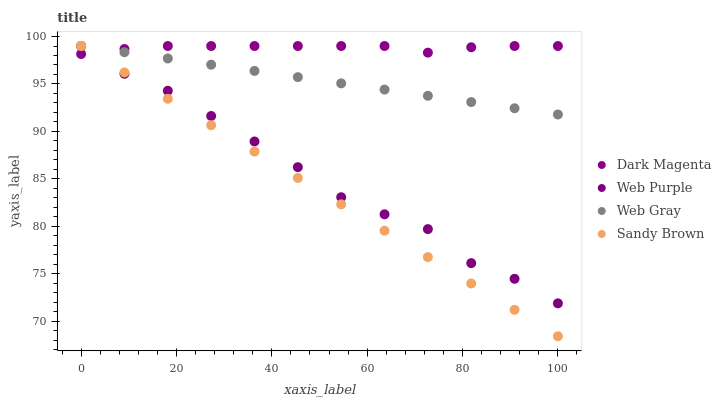Does Sandy Brown have the minimum area under the curve?
Answer yes or no. Yes. Does Dark Magenta have the maximum area under the curve?
Answer yes or no. Yes. Does Web Gray have the minimum area under the curve?
Answer yes or no. No. Does Web Gray have the maximum area under the curve?
Answer yes or no. No. Is Sandy Brown the smoothest?
Answer yes or no. Yes. Is Web Purple the roughest?
Answer yes or no. Yes. Is Web Gray the smoothest?
Answer yes or no. No. Is Web Gray the roughest?
Answer yes or no. No. Does Sandy Brown have the lowest value?
Answer yes or no. Yes. Does Web Gray have the lowest value?
Answer yes or no. No. Does Dark Magenta have the highest value?
Answer yes or no. Yes. Does Dark Magenta intersect Web Purple?
Answer yes or no. Yes. Is Dark Magenta less than Web Purple?
Answer yes or no. No. Is Dark Magenta greater than Web Purple?
Answer yes or no. No. 